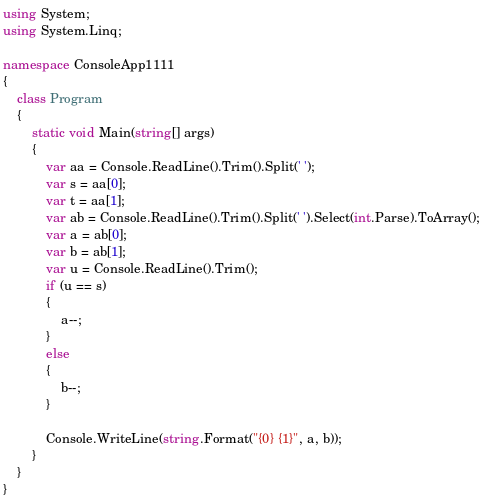<code> <loc_0><loc_0><loc_500><loc_500><_C#_>using System;
using System.Linq;

namespace ConsoleApp1111
{
    class Program
    {
        static void Main(string[] args)
        {
            var aa = Console.ReadLine().Trim().Split(' ');
            var s = aa[0];
            var t = aa[1];
            var ab = Console.ReadLine().Trim().Split(' ').Select(int.Parse).ToArray();
            var a = ab[0];
            var b = ab[1];
            var u = Console.ReadLine().Trim();
            if (u == s)
            {
                a--;
            }
            else
            {
                b--;
            }

            Console.WriteLine(string.Format("{0} {1}", a, b));
        }
    }
}
</code> 